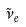<formula> <loc_0><loc_0><loc_500><loc_500>\tilde { \nu } _ { e }</formula> 